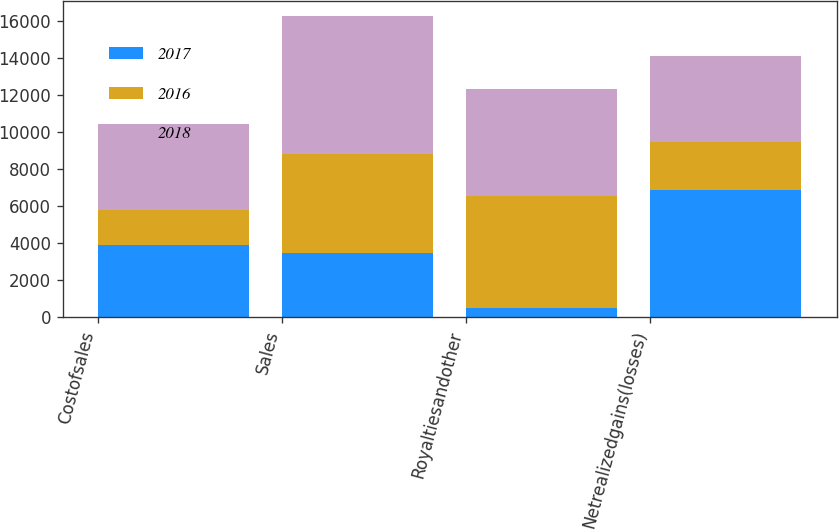<chart> <loc_0><loc_0><loc_500><loc_500><stacked_bar_chart><ecel><fcel>Costofsales<fcel>Sales<fcel>Royaltiesandother<fcel>Netrealizedgains(losses)<nl><fcel>2017<fcel>3909<fcel>3479<fcel>527<fcel>6861<nl><fcel>2016<fcel>1905<fcel>5315<fcel>6000<fcel>2590<nl><fcel>2018<fcel>4612<fcel>7467<fcel>5776<fcel>4612<nl></chart> 